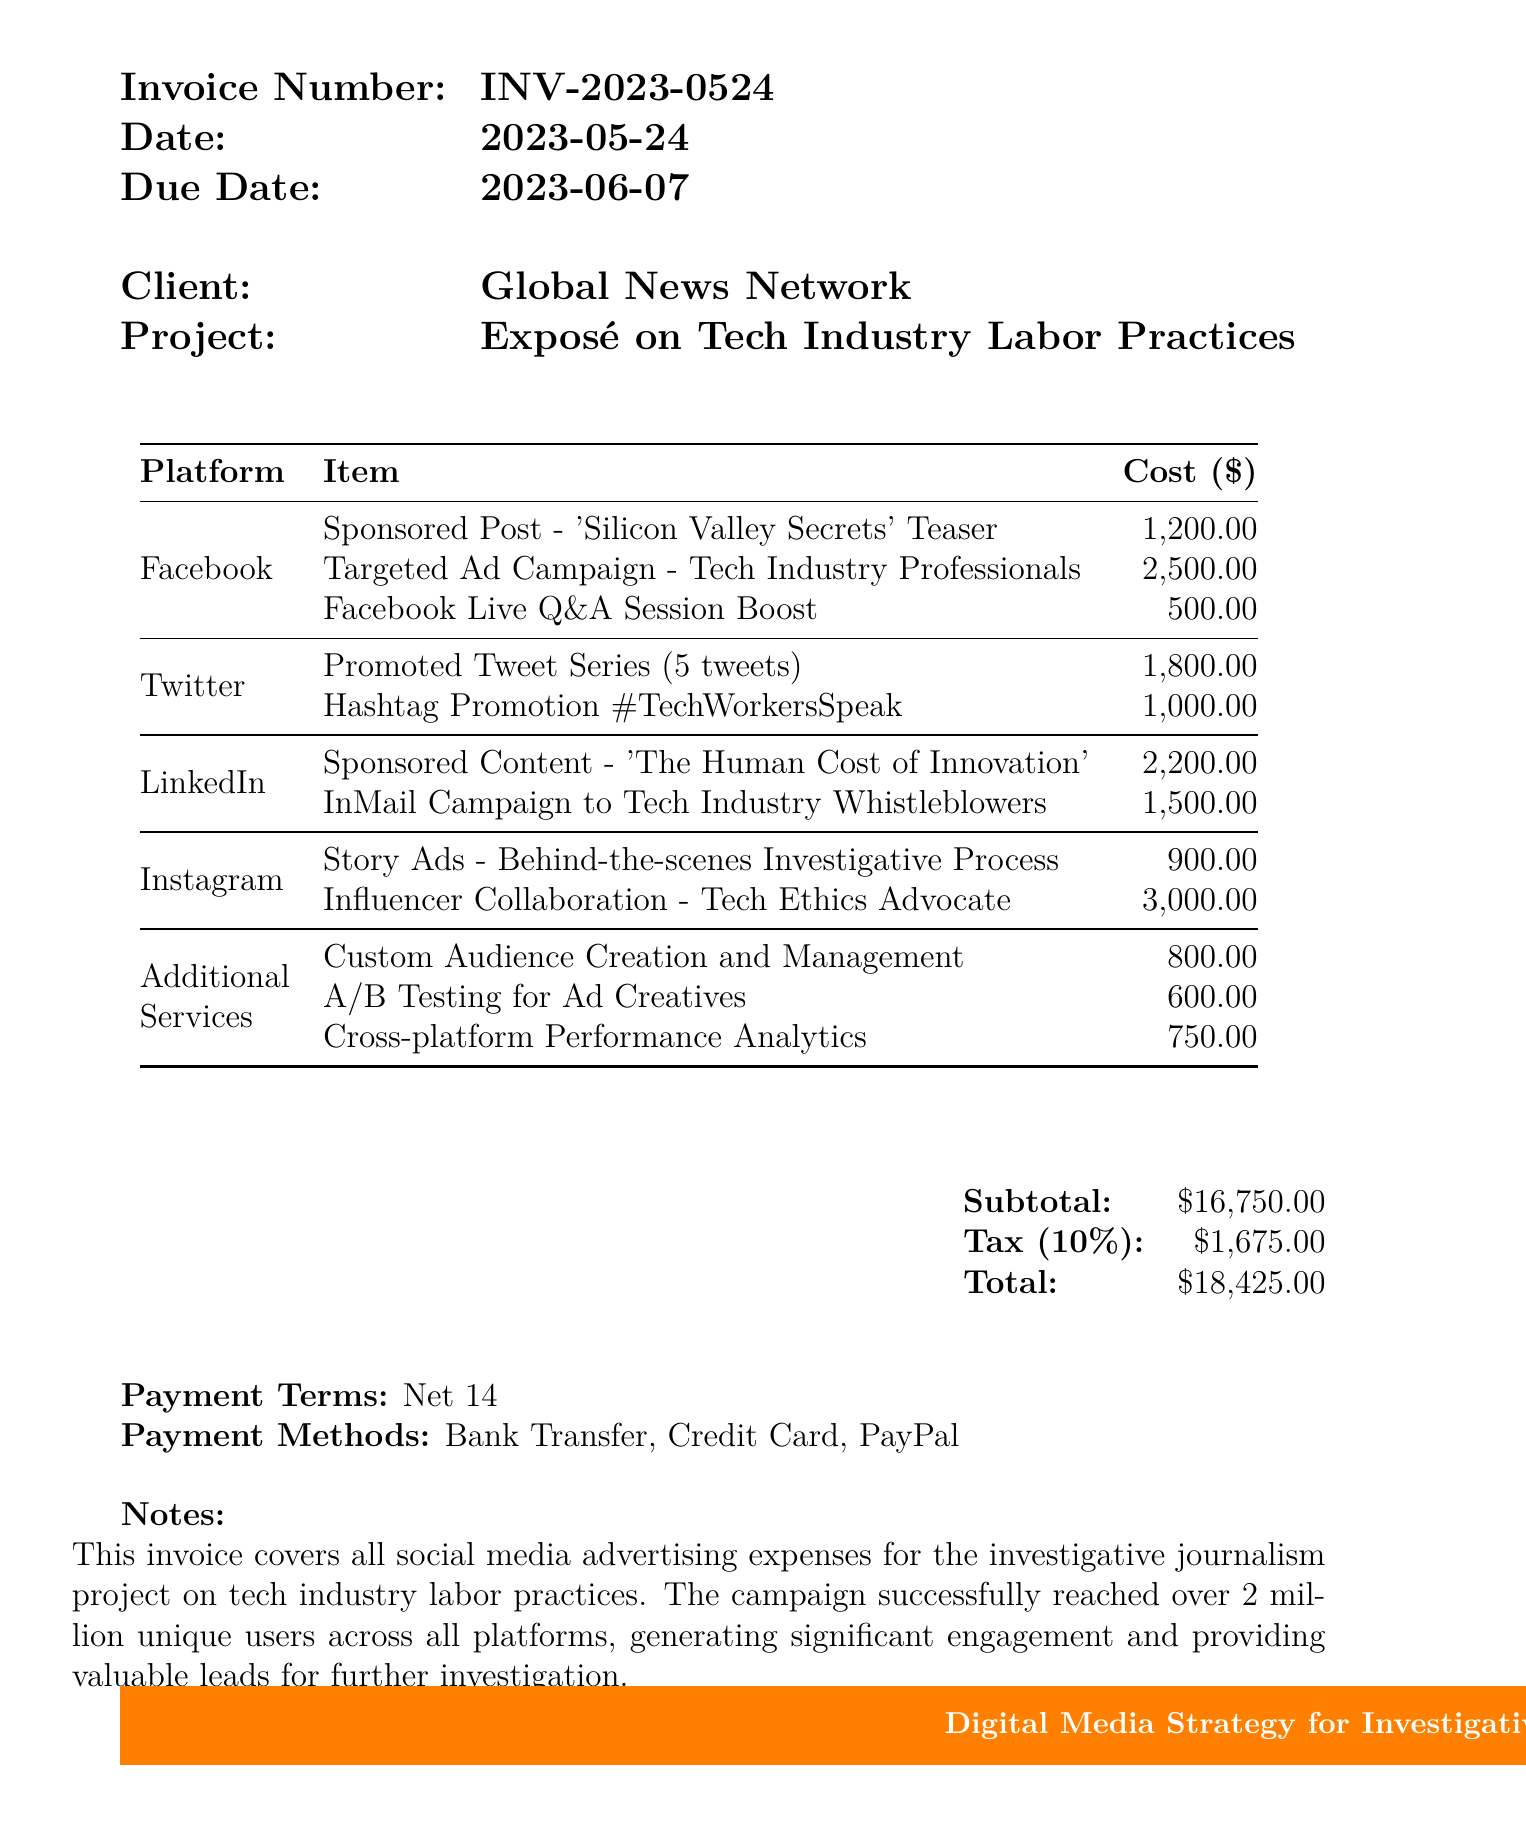What is the invoice number? The invoice number is listed at the top of the document as a unique identifier for this transaction.
Answer: INV-2023-0524 What is the total amount due? The total amount is calculated by adding the subtotal and tax mentioned in the document.
Answer: $18425.00 When is the payment due? The due date is specified in the invoice details section.
Answer: 2023-06-07 What is the subtotal of expenses? The subtotal is the total of all listed expenses before tax, found in the summary section.
Answer: $16750.00 How many unique users did the campaign reach? The document states the campaign's reach in the notes section.
Answer: over 2 million What services were provided on Instagram? This requires looking at the specific platform's expenses in the table.
Answer: Story Ads - Behind-the-scenes Investigative Process, Influencer Collaboration - Tech Ethics Advocate Which payment methods are accepted? The payment methods can be found in a dedicated section towards the end of the document.
Answer: Bank Transfer, Credit Card, PayPal How much was spent on the Facebook ad campaign? This requires summing the specific expenses listed under the Facebook section.
Answer: $4200.00 What are the payment terms? The payment terms are stated clearly in one section of the invoice.
Answer: Net 14 